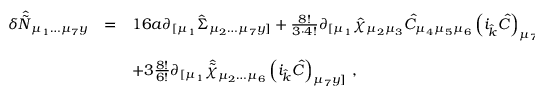Convert formula to latex. <formula><loc_0><loc_0><loc_500><loc_500>\begin{array} { r c l } { { \delta \hat { \tilde { N } } _ { \mu _ { 1 } \dots \mu _ { 7 } y } } } & { = } & { { 1 6 a \partial _ { [ \mu _ { 1 } } \hat { \Sigma } _ { \mu _ { 2 } \dots \mu _ { 7 } y ] } + \frac { 8 ! } { 3 \cdot 4 ! } \partial _ { [ \mu _ { 1 } } \hat { \chi } _ { \mu _ { 2 } \mu _ { 3 } } \hat { C } _ { \mu _ { 4 } \mu _ { 5 } \mu _ { 6 } } \left ( i _ { \hat { k } } \hat { C } \right ) _ { \mu _ { 7 } y ] } } } & { { + 3 \frac { 8 ! } { 6 ! } \partial _ { [ \mu _ { 1 } } \hat { \tilde { \chi } } _ { \mu _ { 2 } \dots \mu _ { 6 } } \left ( i _ { \hat { k } } \hat { C } \right ) _ { \mu _ { 7 } y ] } \, , } } \end{array}</formula> 